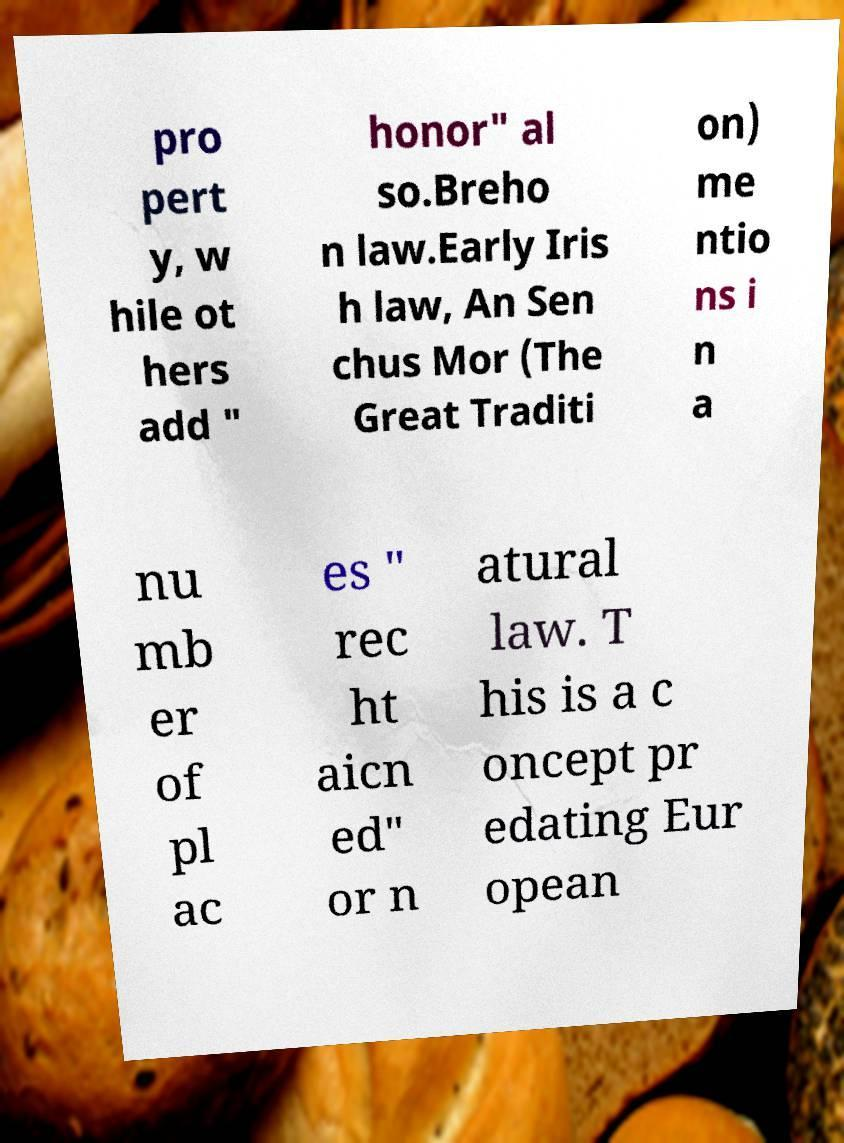For documentation purposes, I need the text within this image transcribed. Could you provide that? pro pert y, w hile ot hers add " honor" al so.Breho n law.Early Iris h law, An Sen chus Mor (The Great Traditi on) me ntio ns i n a nu mb er of pl ac es " rec ht aicn ed" or n atural law. T his is a c oncept pr edating Eur opean 